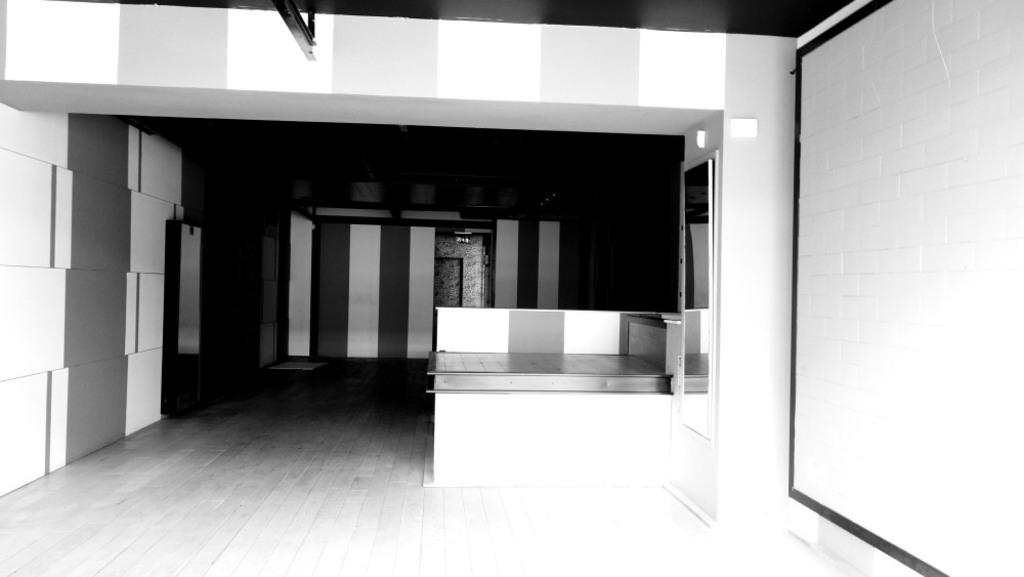What is the color scheme of the image? The image is black and white. What type of structures can be seen in the image? There are walls in the image. What else can be found in the image besides walls? There are objects, a door, a floor, a table, and a mirror on the right side wall in the image. How many children are playing on the table in the image? There are no children present in the image; it only features a table. What type of step can be seen leading up to the mirror in the image? There is no step leading up to the mirror in the image; the mirror is mounted on the wall. 